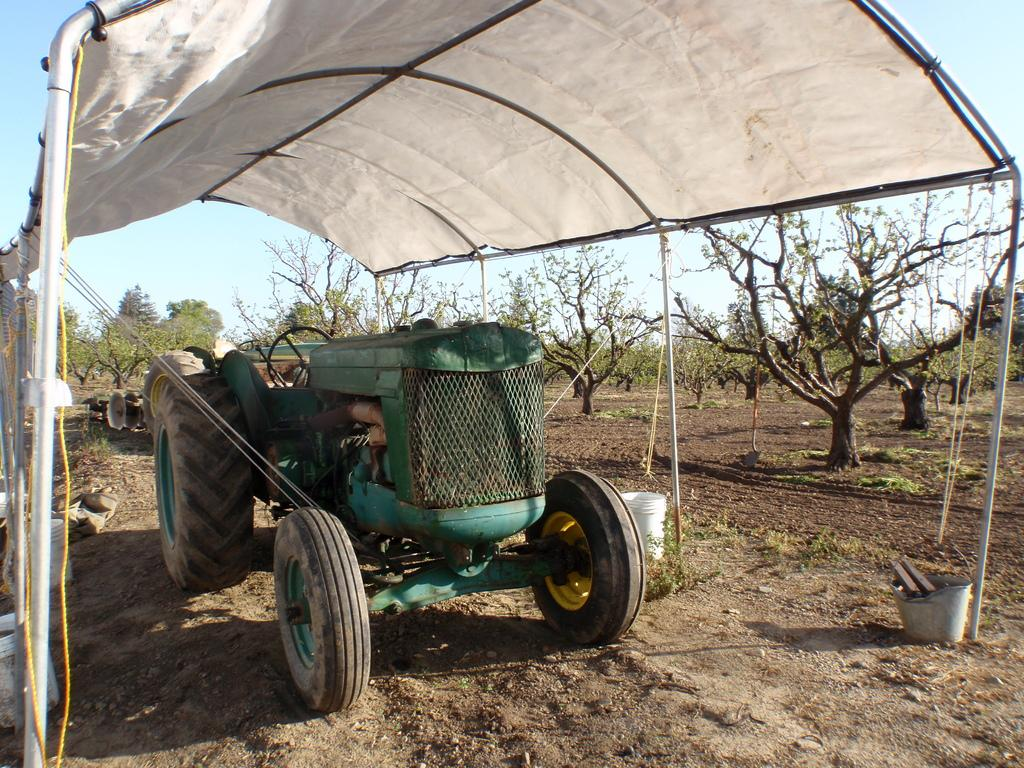What type of vehicle is in the image? There is a tractor in the image. What structure can be seen in the image? There is a shelter in the image. What type of vegetation is present in the image? There are trees with branches and leaves in the image. What objects are used for holding or carrying in the image? There are buckets in the image. What color of ink is being used to write on the tractor in the image? There is no ink or writing present on the tractor in the image. What emotion is the tractor displaying in the image? Tractors do not have emotions, as they are inanimate objects. 